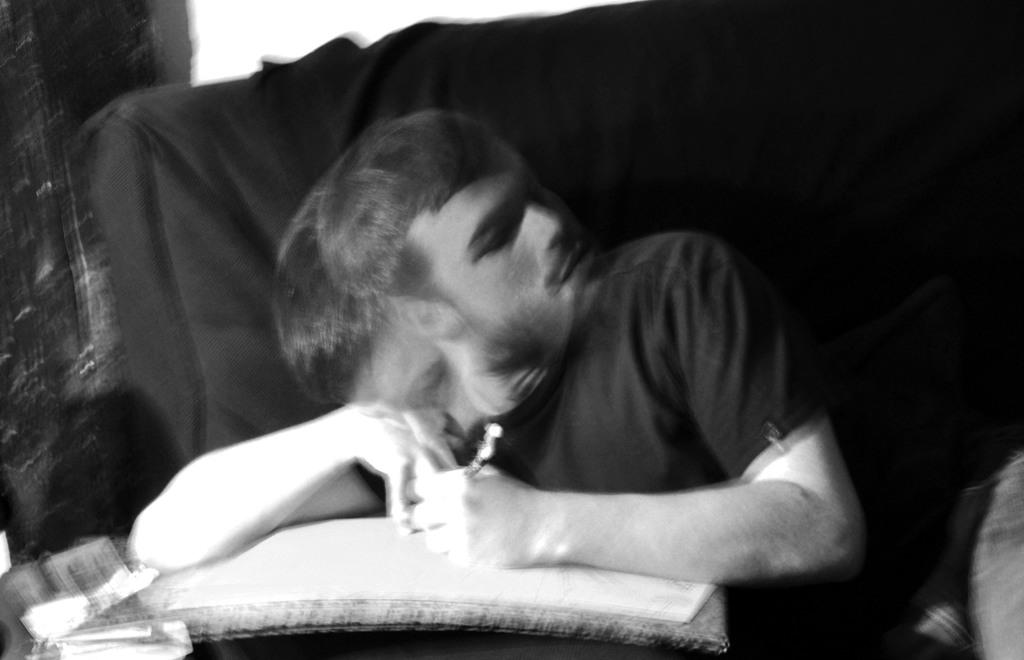What is the main subject of the image? There is a person in the image. What is the person doing in the image? The person is sitting. What is the person holding in their hand? The person is holding something in their hand, but the specific object is not mentioned in the facts. What is the color scheme of the image? The image is black and white. What type of linen is draped over the border in the image? There is no mention of linen or a border in the image, so this question cannot be answered definitively. 